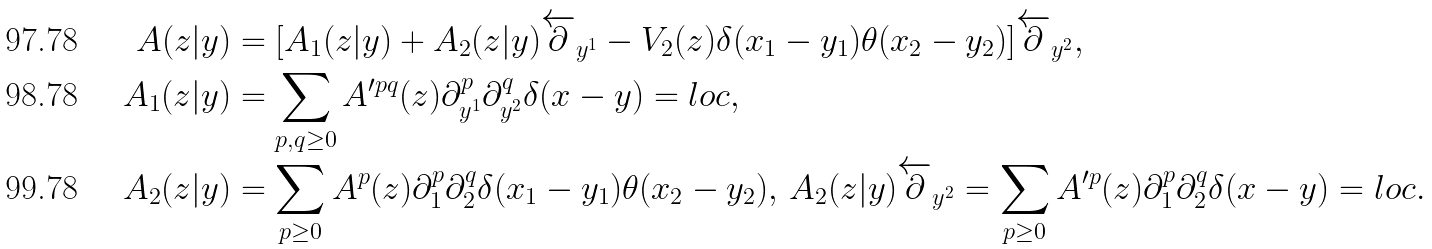<formula> <loc_0><loc_0><loc_500><loc_500>A ( z | y ) & = [ A _ { 1 } ( z | y ) + A _ { 2 } ( z | y ) \overleftarrow { \partial } _ { y ^ { 1 } } - V _ { 2 } ( z ) \delta ( x _ { 1 } - y _ { 1 } ) \theta ( x _ { 2 } - y _ { 2 } ) ] \overleftarrow { \partial } _ { y ^ { 2 } } , \\ A _ { 1 } ( z | y ) & = \sum _ { p , q \geq 0 } A ^ { \prime p q } ( z ) \partial _ { y ^ { 1 } } ^ { p } \partial _ { y ^ { 2 } } ^ { q } \delta ( x - y ) = l o c , \\ A _ { 2 } ( z | y ) & = \sum _ { p \geq 0 } A ^ { p } ( z ) \partial _ { 1 } ^ { p } \partial _ { 2 } ^ { q } \delta ( x _ { 1 } - y _ { 1 } ) \theta ( x _ { 2 } - y _ { 2 } ) , \, A _ { 2 } ( z | y ) \overleftarrow { \partial } _ { y ^ { 2 } } = \sum _ { p \geq 0 } A ^ { \prime p } ( z ) \partial _ { 1 } ^ { p } \partial _ { 2 } ^ { q } \delta ( x - y ) = l o c .</formula> 